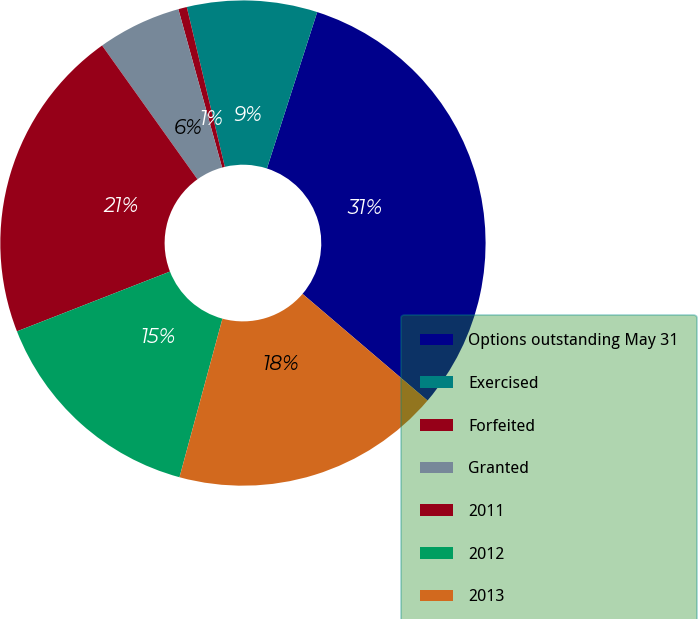Convert chart to OTSL. <chart><loc_0><loc_0><loc_500><loc_500><pie_chart><fcel>Options outstanding May 31<fcel>Exercised<fcel>Forfeited<fcel>Granted<fcel>2011<fcel>2012<fcel>2013<nl><fcel>31.29%<fcel>8.67%<fcel>0.57%<fcel>5.57%<fcel>21.07%<fcel>14.86%<fcel>17.97%<nl></chart> 